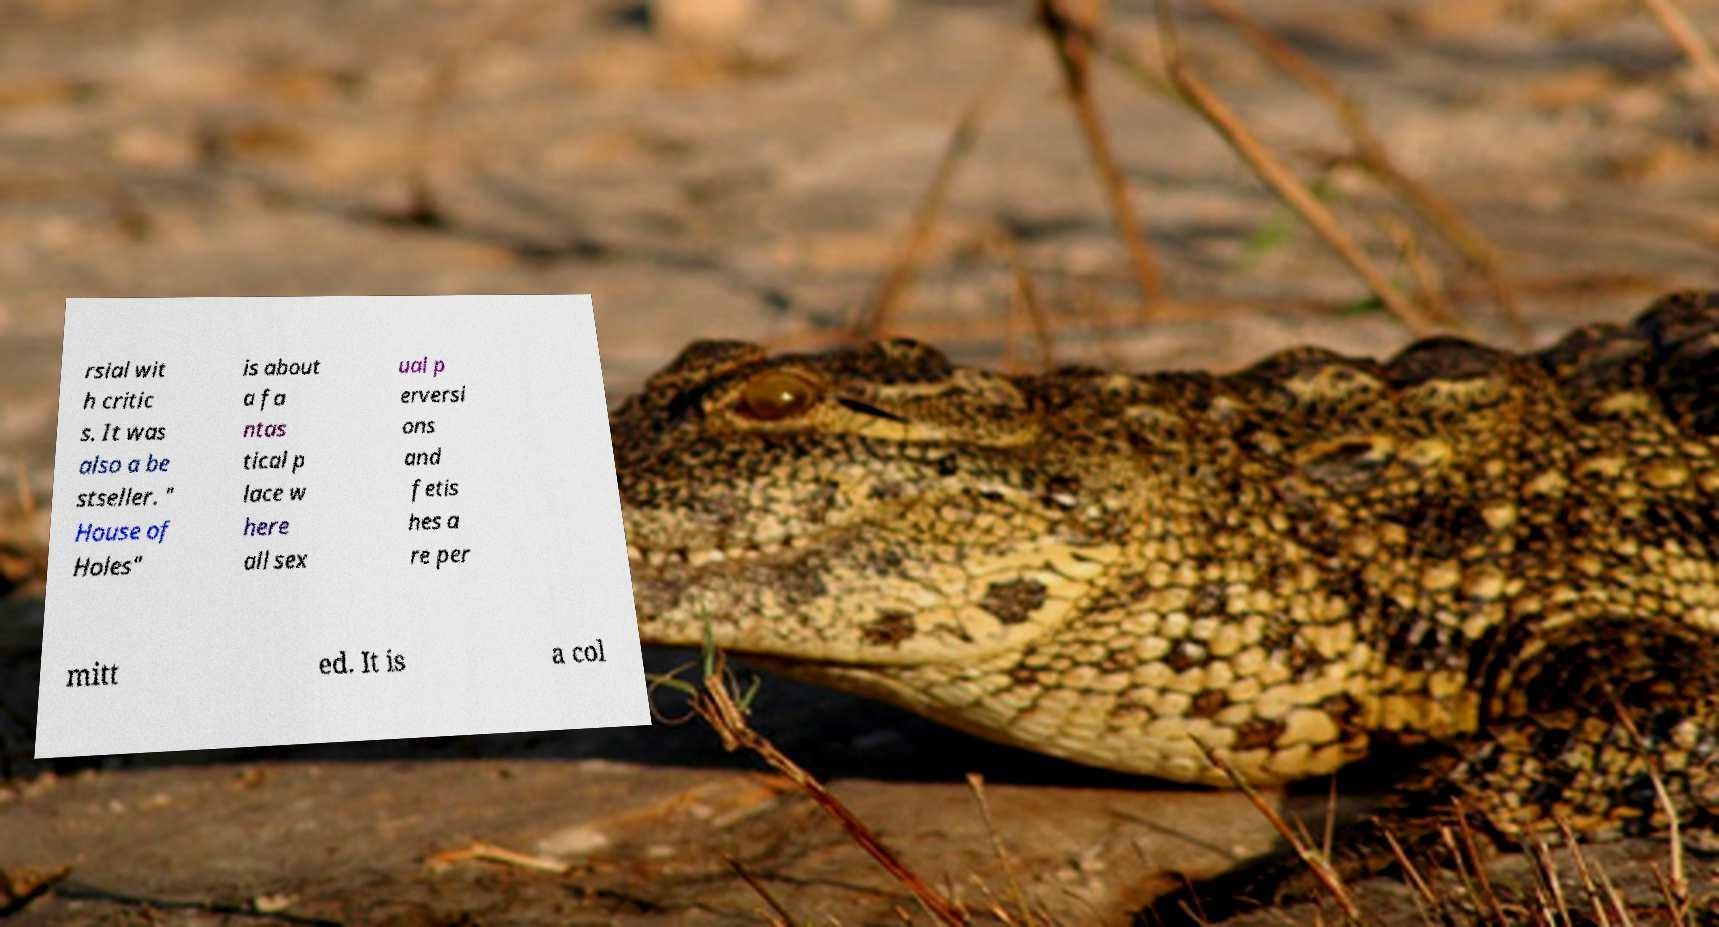Could you assist in decoding the text presented in this image and type it out clearly? rsial wit h critic s. It was also a be stseller. " House of Holes" is about a fa ntas tical p lace w here all sex ual p erversi ons and fetis hes a re per mitt ed. It is a col 